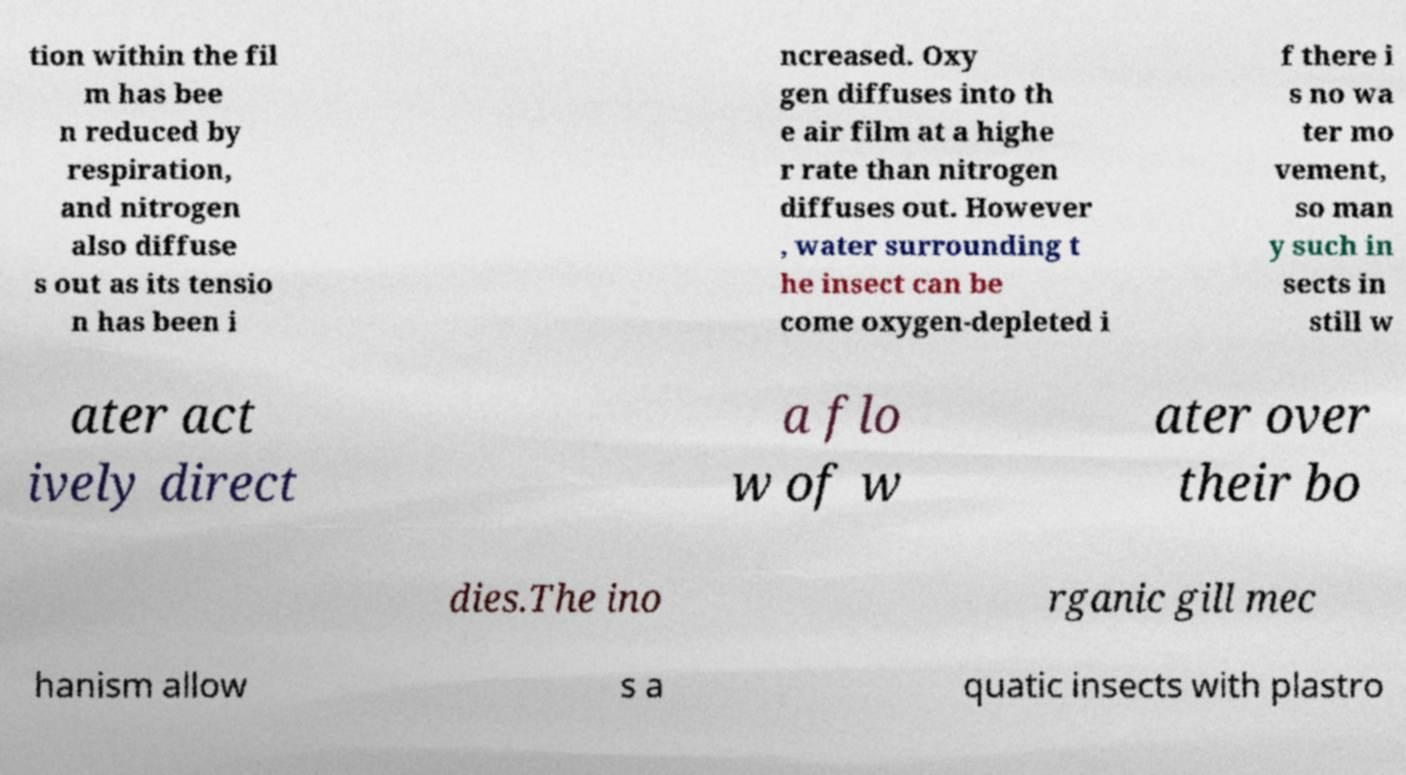What messages or text are displayed in this image? I need them in a readable, typed format. tion within the fil m has bee n reduced by respiration, and nitrogen also diffuse s out as its tensio n has been i ncreased. Oxy gen diffuses into th e air film at a highe r rate than nitrogen diffuses out. However , water surrounding t he insect can be come oxygen-depleted i f there i s no wa ter mo vement, so man y such in sects in still w ater act ively direct a flo w of w ater over their bo dies.The ino rganic gill mec hanism allow s a quatic insects with plastro 